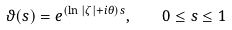Convert formula to latex. <formula><loc_0><loc_0><loc_500><loc_500>\vartheta ( s ) = e ^ { ( \ln | \zeta | + i \theta ) s } , \quad 0 \leq s \leq 1</formula> 